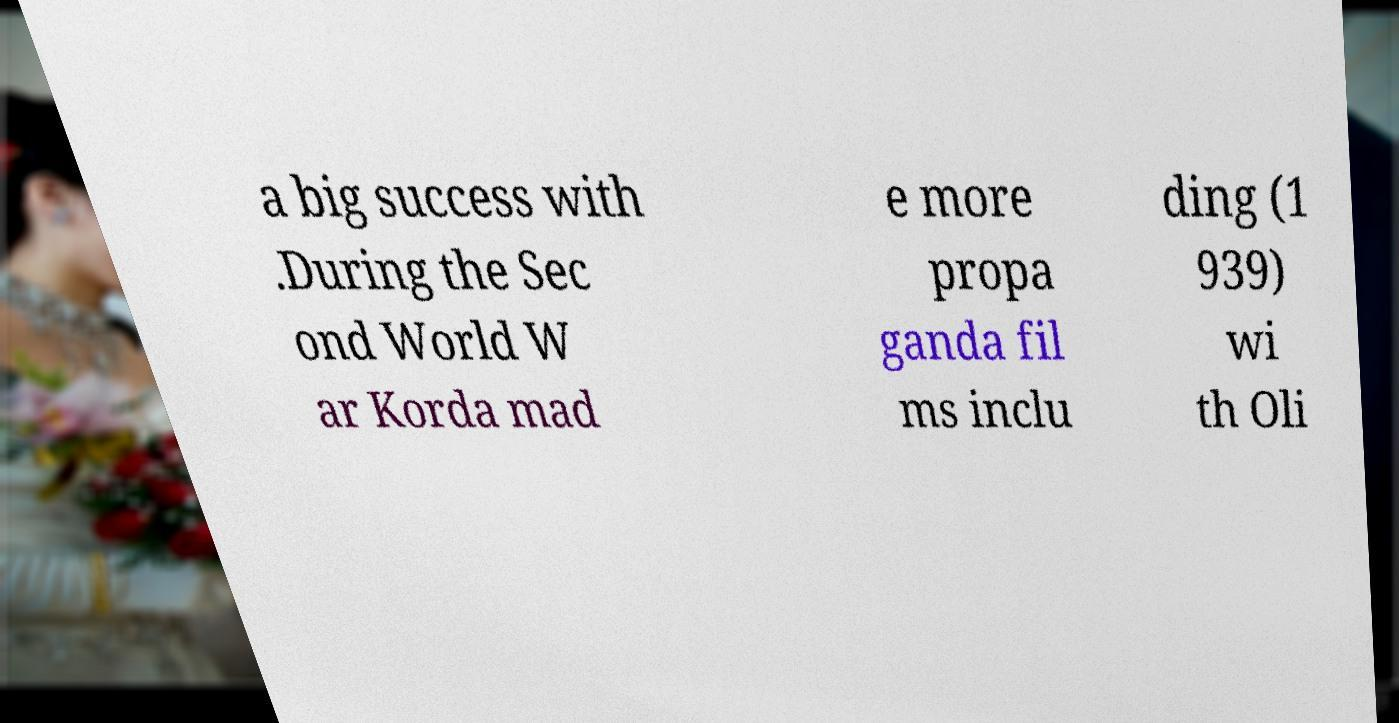Please read and relay the text visible in this image. What does it say? a big success with .During the Sec ond World W ar Korda mad e more propa ganda fil ms inclu ding (1 939) wi th Oli 